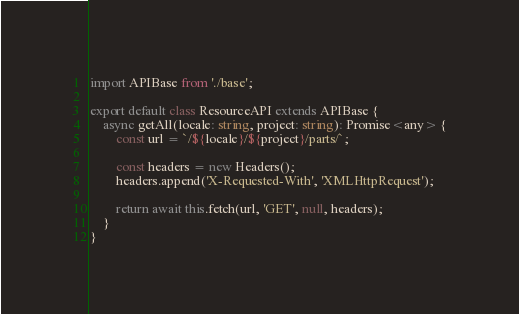<code> <loc_0><loc_0><loc_500><loc_500><_TypeScript_>import APIBase from './base';

export default class ResourceAPI extends APIBase {
    async getAll(locale: string, project: string): Promise<any> {
        const url = `/${locale}/${project}/parts/`;

        const headers = new Headers();
        headers.append('X-Requested-With', 'XMLHttpRequest');

        return await this.fetch(url, 'GET', null, headers);
    }
}
</code> 